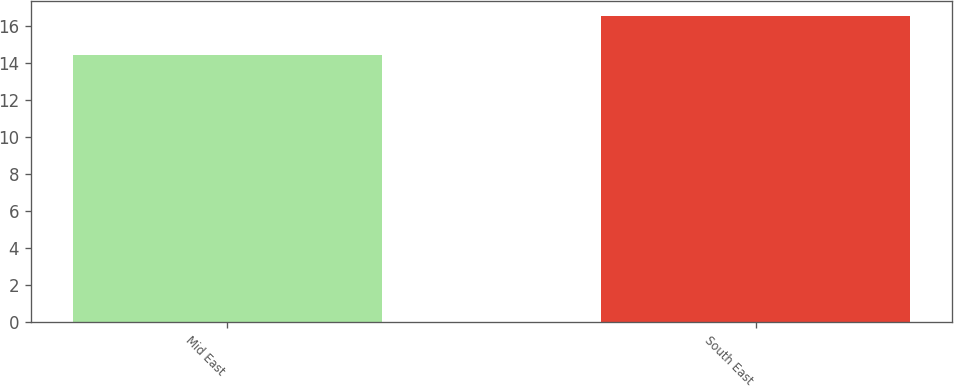Convert chart to OTSL. <chart><loc_0><loc_0><loc_500><loc_500><bar_chart><fcel>Mid East<fcel>South East<nl><fcel>14.4<fcel>16.5<nl></chart> 